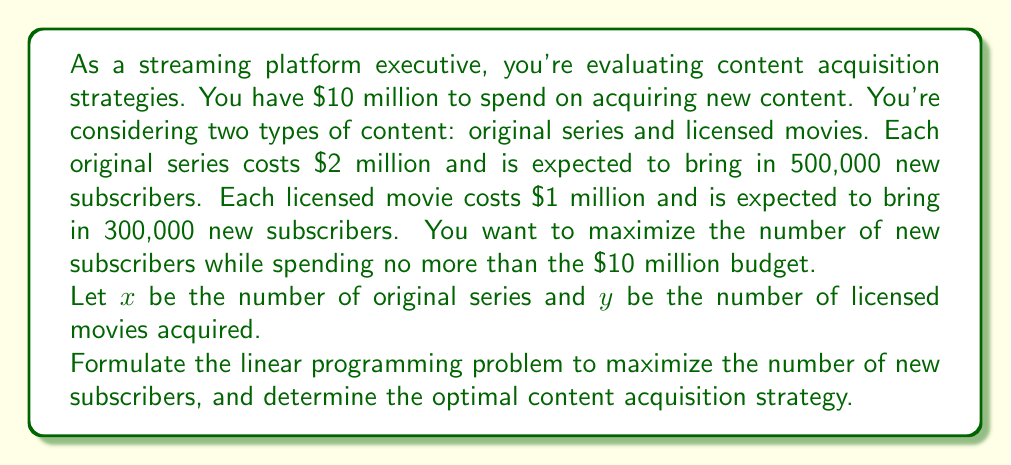Give your solution to this math problem. Let's approach this step-by-step:

1) First, we need to formulate the objective function. We want to maximize the number of new subscribers:
   
   Maximize: $500,000x + 300,000y$

2) Now, we need to consider the constraints:

   a) Budget constraint: $2,000,000x + 1,000,000y \leq 10,000,000$
      Simplifying: $2x + y \leq 10$

   b) Non-negativity constraints: $x \geq 0$, $y \geq 0$

3) Our linear programming problem is now:

   Maximize: $500,000x + 300,000y$
   Subject to:
   $2x + y \leq 10$
   $x \geq 0$, $y \geq 0$

4) To solve this, we can use the corner point method. The feasible region is bounded by:
   $x = 0$, $y = 0$, and $2x + y = 10$

5) The corner points are:
   (0, 0), (0, 10), (5, 0)

6) Evaluating the objective function at each point:
   At (0, 0): $500,000(0) + 300,000(0) = 0$
   At (0, 10): $500,000(0) + 300,000(10) = 3,000,000$
   At (5, 0): $500,000(5) + 300,000(0) = 2,500,000$

7) The maximum value occurs at (0, 10), which means acquiring 10 licensed movies and 0 original series.
Answer: The optimal content acquisition strategy is to acquire 10 licensed movies and 0 original series. This strategy is expected to bring in 3,000,000 new subscribers. 